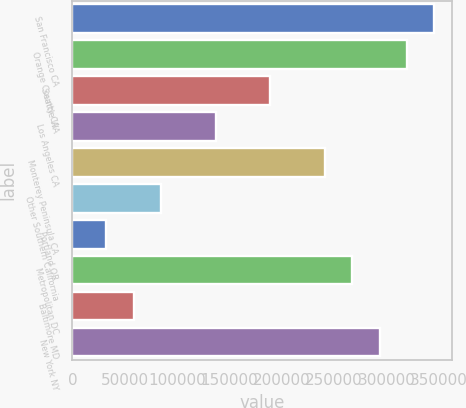Convert chart to OTSL. <chart><loc_0><loc_0><loc_500><loc_500><bar_chart><fcel>San Francisco CA<fcel>Orange County CA<fcel>Seattle WA<fcel>Los Angeles CA<fcel>Monterey Peninsula CA<fcel>Other Southern California<fcel>Portland OR<fcel>Metropolitan DC<fcel>Baltimore MD<fcel>New York NY<nl><fcel>345943<fcel>319818<fcel>189195<fcel>136946<fcel>241444<fcel>84696.1<fcel>32446.7<fcel>267569<fcel>58571.4<fcel>293694<nl></chart> 